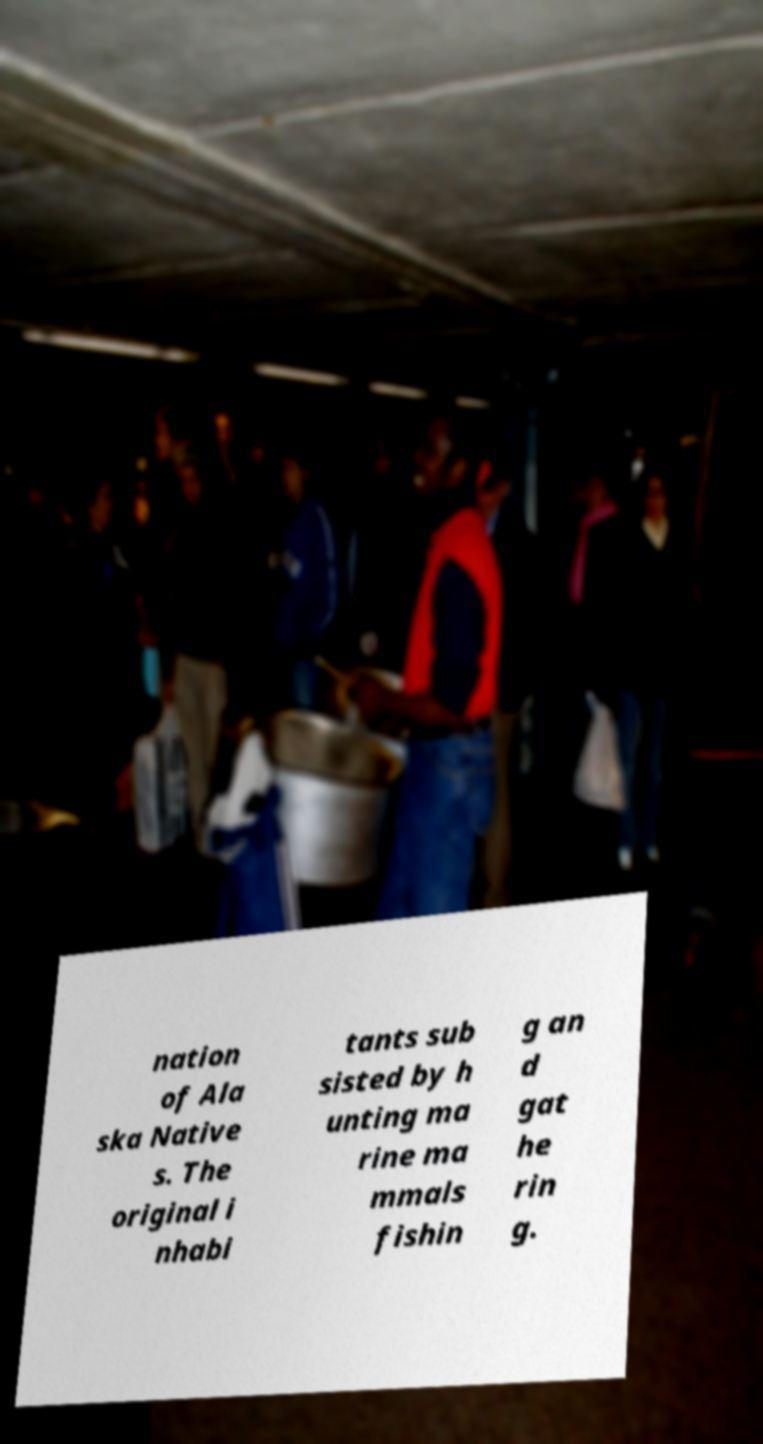Can you read and provide the text displayed in the image?This photo seems to have some interesting text. Can you extract and type it out for me? nation of Ala ska Native s. The original i nhabi tants sub sisted by h unting ma rine ma mmals fishin g an d gat he rin g. 